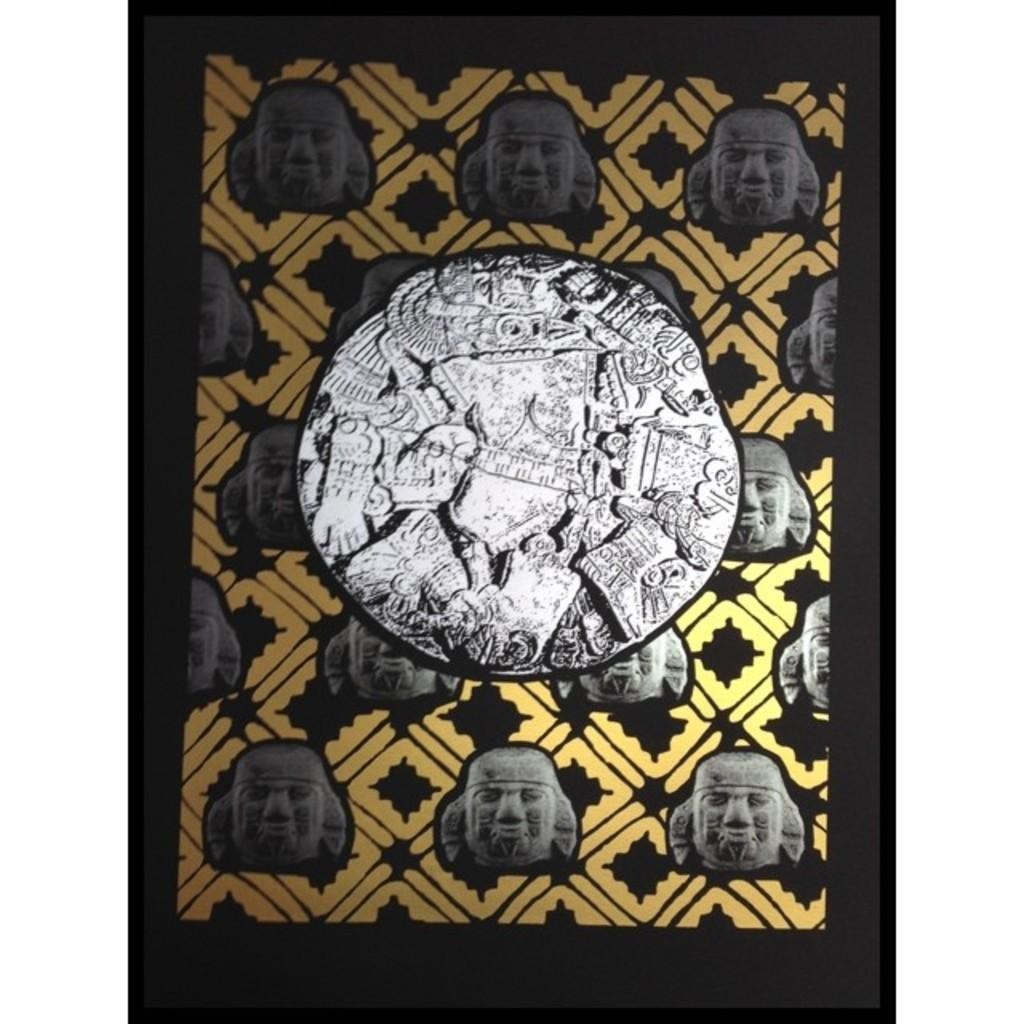What type of objects are depicted in the image? There are face sculptures of different people in the image. Where are the face sculptures located? The face sculptures are on a picture. What type of meal is being served in the image? There is no meal present in the image; it features face sculptures on a picture. What thrilling activity is taking place in the image? There is no thrilling activity depicted in the image; it features face sculptures on a picture. 